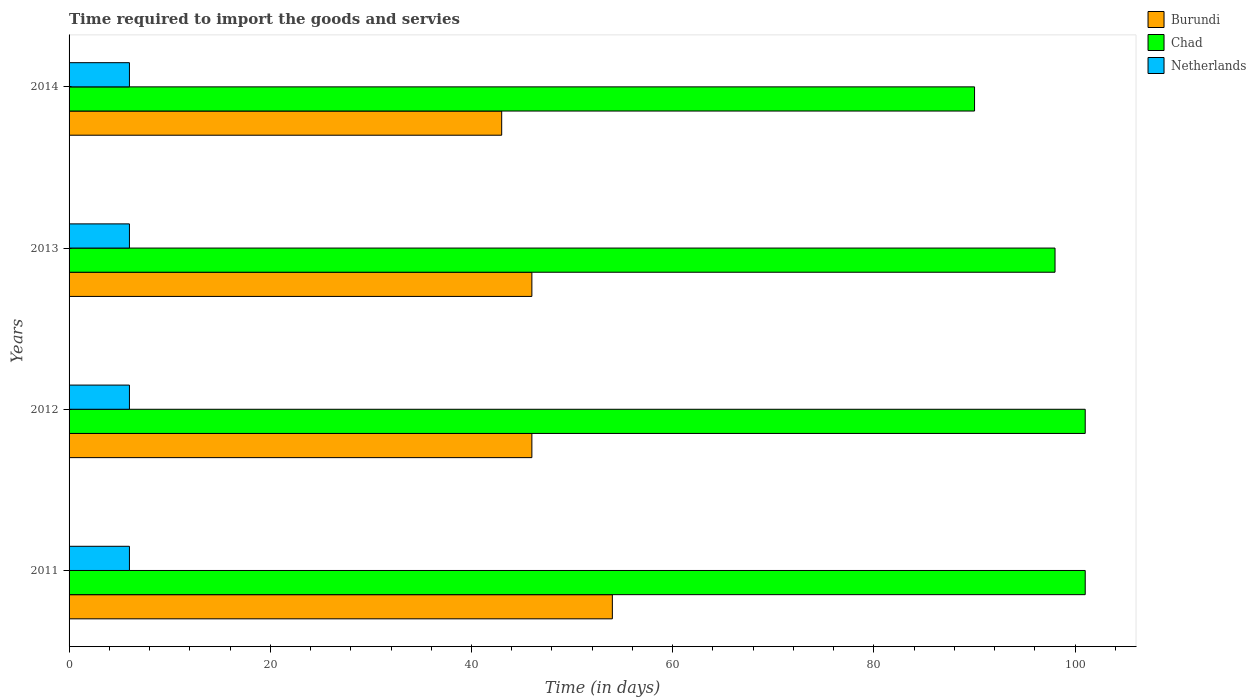Are the number of bars per tick equal to the number of legend labels?
Make the answer very short. Yes. How many bars are there on the 3rd tick from the top?
Your answer should be compact. 3. What is the label of the 3rd group of bars from the top?
Provide a succinct answer. 2012. In how many cases, is the number of bars for a given year not equal to the number of legend labels?
Provide a succinct answer. 0. Across all years, what is the maximum number of days required to import the goods and services in Chad?
Offer a very short reply. 101. Across all years, what is the minimum number of days required to import the goods and services in Netherlands?
Your answer should be compact. 6. In which year was the number of days required to import the goods and services in Burundi maximum?
Keep it short and to the point. 2011. What is the total number of days required to import the goods and services in Netherlands in the graph?
Keep it short and to the point. 24. What is the difference between the number of days required to import the goods and services in Chad in 2011 and that in 2014?
Provide a succinct answer. 11. What is the difference between the number of days required to import the goods and services in Chad in 2013 and the number of days required to import the goods and services in Burundi in 2012?
Give a very brief answer. 52. What is the average number of days required to import the goods and services in Burundi per year?
Offer a terse response. 47.25. In the year 2011, what is the difference between the number of days required to import the goods and services in Burundi and number of days required to import the goods and services in Chad?
Keep it short and to the point. -47. What is the ratio of the number of days required to import the goods and services in Chad in 2011 to that in 2014?
Your response must be concise. 1.12. Is the difference between the number of days required to import the goods and services in Burundi in 2012 and 2014 greater than the difference between the number of days required to import the goods and services in Chad in 2012 and 2014?
Ensure brevity in your answer.  No. What is the difference between the highest and the lowest number of days required to import the goods and services in Burundi?
Offer a terse response. 11. In how many years, is the number of days required to import the goods and services in Chad greater than the average number of days required to import the goods and services in Chad taken over all years?
Your response must be concise. 3. Is the sum of the number of days required to import the goods and services in Netherlands in 2012 and 2013 greater than the maximum number of days required to import the goods and services in Burundi across all years?
Your response must be concise. No. What does the 2nd bar from the top in 2013 represents?
Your response must be concise. Chad. What does the 3rd bar from the bottom in 2013 represents?
Your response must be concise. Netherlands. How many bars are there?
Your answer should be compact. 12. How many years are there in the graph?
Your answer should be compact. 4. Does the graph contain any zero values?
Keep it short and to the point. No. Does the graph contain grids?
Provide a short and direct response. No. What is the title of the graph?
Keep it short and to the point. Time required to import the goods and servies. What is the label or title of the X-axis?
Provide a short and direct response. Time (in days). What is the Time (in days) of Burundi in 2011?
Make the answer very short. 54. What is the Time (in days) in Chad in 2011?
Offer a very short reply. 101. What is the Time (in days) in Netherlands in 2011?
Offer a very short reply. 6. What is the Time (in days) of Burundi in 2012?
Make the answer very short. 46. What is the Time (in days) of Chad in 2012?
Your response must be concise. 101. What is the Time (in days) in Burundi in 2013?
Ensure brevity in your answer.  46. What is the Time (in days) in Chad in 2013?
Your answer should be compact. 98. What is the Time (in days) of Burundi in 2014?
Keep it short and to the point. 43. Across all years, what is the maximum Time (in days) of Burundi?
Your answer should be compact. 54. Across all years, what is the maximum Time (in days) of Chad?
Provide a succinct answer. 101. Across all years, what is the minimum Time (in days) in Burundi?
Offer a terse response. 43. Across all years, what is the minimum Time (in days) of Chad?
Provide a succinct answer. 90. What is the total Time (in days) of Burundi in the graph?
Provide a short and direct response. 189. What is the total Time (in days) of Chad in the graph?
Provide a short and direct response. 390. What is the difference between the Time (in days) of Burundi in 2011 and that in 2012?
Keep it short and to the point. 8. What is the difference between the Time (in days) in Netherlands in 2011 and that in 2012?
Ensure brevity in your answer.  0. What is the difference between the Time (in days) of Chad in 2011 and that in 2013?
Your answer should be compact. 3. What is the difference between the Time (in days) of Chad in 2011 and that in 2014?
Make the answer very short. 11. What is the difference between the Time (in days) of Burundi in 2012 and that in 2013?
Ensure brevity in your answer.  0. What is the difference between the Time (in days) of Chad in 2012 and that in 2013?
Keep it short and to the point. 3. What is the difference between the Time (in days) of Burundi in 2012 and that in 2014?
Your answer should be compact. 3. What is the difference between the Time (in days) in Chad in 2012 and that in 2014?
Provide a short and direct response. 11. What is the difference between the Time (in days) in Netherlands in 2012 and that in 2014?
Make the answer very short. 0. What is the difference between the Time (in days) in Netherlands in 2013 and that in 2014?
Make the answer very short. 0. What is the difference between the Time (in days) in Burundi in 2011 and the Time (in days) in Chad in 2012?
Your response must be concise. -47. What is the difference between the Time (in days) of Burundi in 2011 and the Time (in days) of Netherlands in 2012?
Your response must be concise. 48. What is the difference between the Time (in days) in Burundi in 2011 and the Time (in days) in Chad in 2013?
Your answer should be very brief. -44. What is the difference between the Time (in days) in Burundi in 2011 and the Time (in days) in Netherlands in 2013?
Provide a succinct answer. 48. What is the difference between the Time (in days) in Chad in 2011 and the Time (in days) in Netherlands in 2013?
Your answer should be compact. 95. What is the difference between the Time (in days) in Burundi in 2011 and the Time (in days) in Chad in 2014?
Offer a terse response. -36. What is the difference between the Time (in days) in Burundi in 2011 and the Time (in days) in Netherlands in 2014?
Your answer should be compact. 48. What is the difference between the Time (in days) of Burundi in 2012 and the Time (in days) of Chad in 2013?
Offer a terse response. -52. What is the difference between the Time (in days) of Burundi in 2012 and the Time (in days) of Netherlands in 2013?
Your response must be concise. 40. What is the difference between the Time (in days) of Chad in 2012 and the Time (in days) of Netherlands in 2013?
Provide a short and direct response. 95. What is the difference between the Time (in days) of Burundi in 2012 and the Time (in days) of Chad in 2014?
Keep it short and to the point. -44. What is the difference between the Time (in days) of Burundi in 2012 and the Time (in days) of Netherlands in 2014?
Your answer should be very brief. 40. What is the difference between the Time (in days) of Chad in 2012 and the Time (in days) of Netherlands in 2014?
Keep it short and to the point. 95. What is the difference between the Time (in days) of Burundi in 2013 and the Time (in days) of Chad in 2014?
Provide a short and direct response. -44. What is the difference between the Time (in days) in Burundi in 2013 and the Time (in days) in Netherlands in 2014?
Provide a succinct answer. 40. What is the difference between the Time (in days) in Chad in 2013 and the Time (in days) in Netherlands in 2014?
Keep it short and to the point. 92. What is the average Time (in days) in Burundi per year?
Offer a terse response. 47.25. What is the average Time (in days) in Chad per year?
Provide a short and direct response. 97.5. What is the average Time (in days) of Netherlands per year?
Provide a short and direct response. 6. In the year 2011, what is the difference between the Time (in days) in Burundi and Time (in days) in Chad?
Your answer should be very brief. -47. In the year 2012, what is the difference between the Time (in days) in Burundi and Time (in days) in Chad?
Give a very brief answer. -55. In the year 2012, what is the difference between the Time (in days) of Burundi and Time (in days) of Netherlands?
Make the answer very short. 40. In the year 2012, what is the difference between the Time (in days) in Chad and Time (in days) in Netherlands?
Your answer should be very brief. 95. In the year 2013, what is the difference between the Time (in days) in Burundi and Time (in days) in Chad?
Offer a terse response. -52. In the year 2013, what is the difference between the Time (in days) of Chad and Time (in days) of Netherlands?
Provide a succinct answer. 92. In the year 2014, what is the difference between the Time (in days) of Burundi and Time (in days) of Chad?
Your response must be concise. -47. In the year 2014, what is the difference between the Time (in days) of Burundi and Time (in days) of Netherlands?
Your answer should be compact. 37. In the year 2014, what is the difference between the Time (in days) of Chad and Time (in days) of Netherlands?
Make the answer very short. 84. What is the ratio of the Time (in days) of Burundi in 2011 to that in 2012?
Keep it short and to the point. 1.17. What is the ratio of the Time (in days) in Chad in 2011 to that in 2012?
Provide a succinct answer. 1. What is the ratio of the Time (in days) of Netherlands in 2011 to that in 2012?
Make the answer very short. 1. What is the ratio of the Time (in days) in Burundi in 2011 to that in 2013?
Give a very brief answer. 1.17. What is the ratio of the Time (in days) in Chad in 2011 to that in 2013?
Ensure brevity in your answer.  1.03. What is the ratio of the Time (in days) of Netherlands in 2011 to that in 2013?
Your answer should be compact. 1. What is the ratio of the Time (in days) of Burundi in 2011 to that in 2014?
Your answer should be compact. 1.26. What is the ratio of the Time (in days) of Chad in 2011 to that in 2014?
Offer a terse response. 1.12. What is the ratio of the Time (in days) of Chad in 2012 to that in 2013?
Your response must be concise. 1.03. What is the ratio of the Time (in days) of Burundi in 2012 to that in 2014?
Make the answer very short. 1.07. What is the ratio of the Time (in days) of Chad in 2012 to that in 2014?
Ensure brevity in your answer.  1.12. What is the ratio of the Time (in days) in Burundi in 2013 to that in 2014?
Ensure brevity in your answer.  1.07. What is the ratio of the Time (in days) of Chad in 2013 to that in 2014?
Keep it short and to the point. 1.09. What is the difference between the highest and the second highest Time (in days) of Netherlands?
Your response must be concise. 0. What is the difference between the highest and the lowest Time (in days) in Chad?
Offer a terse response. 11. What is the difference between the highest and the lowest Time (in days) of Netherlands?
Keep it short and to the point. 0. 